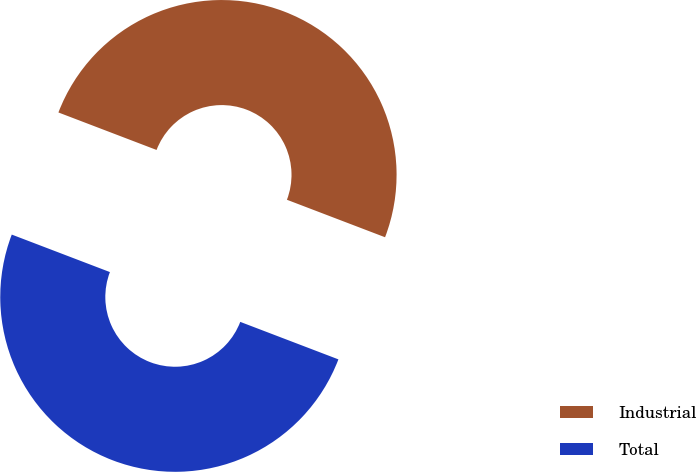Convert chart to OTSL. <chart><loc_0><loc_0><loc_500><loc_500><pie_chart><fcel>Industrial<fcel>Total<nl><fcel>50.0%<fcel>50.0%<nl></chart> 